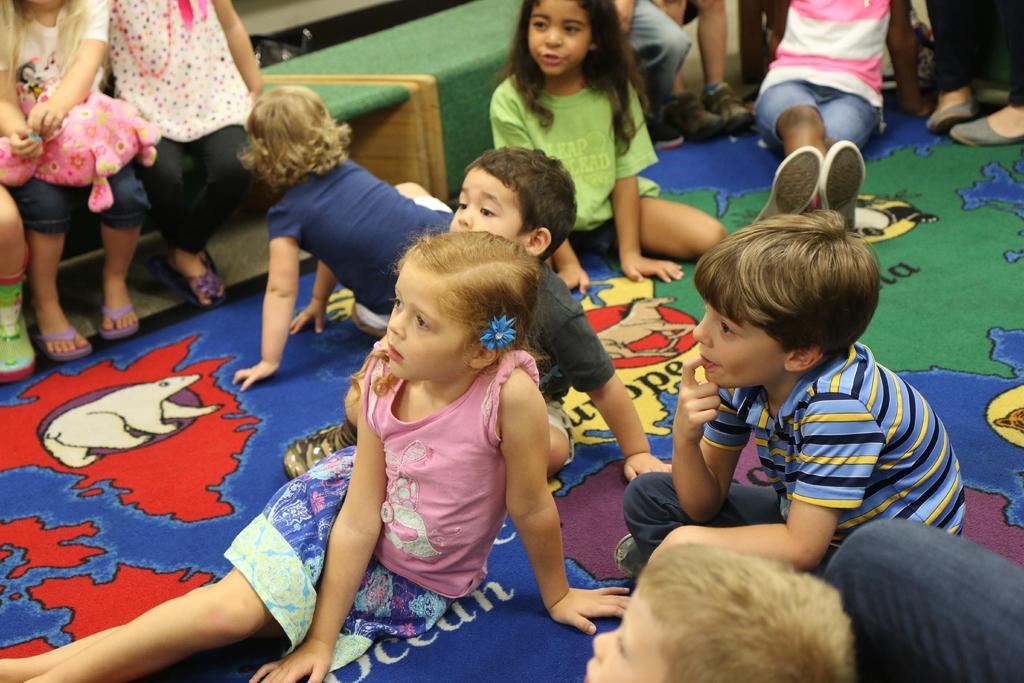Can you describe this image briefly? In this image we can see these children are sitting on the carpet and these children are sitting on the bench. 